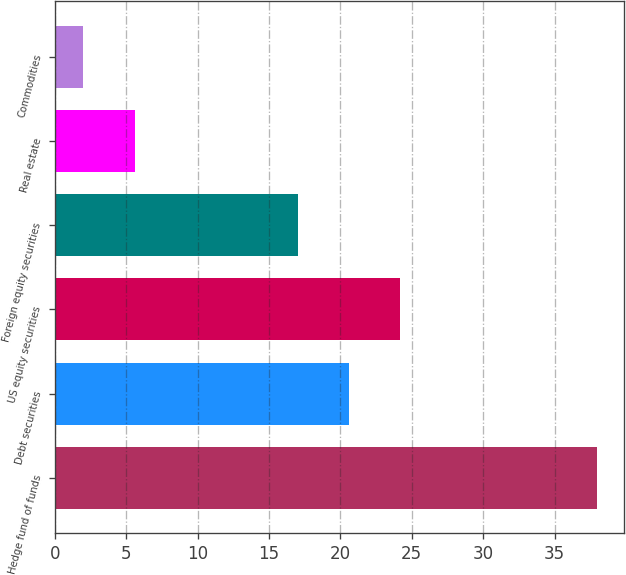Convert chart. <chart><loc_0><loc_0><loc_500><loc_500><bar_chart><fcel>Hedge fund of funds<fcel>Debt securities<fcel>US equity securities<fcel>Foreign equity securities<fcel>Real estate<fcel>Commodities<nl><fcel>38<fcel>20.6<fcel>24.2<fcel>17<fcel>5.6<fcel>2<nl></chart> 